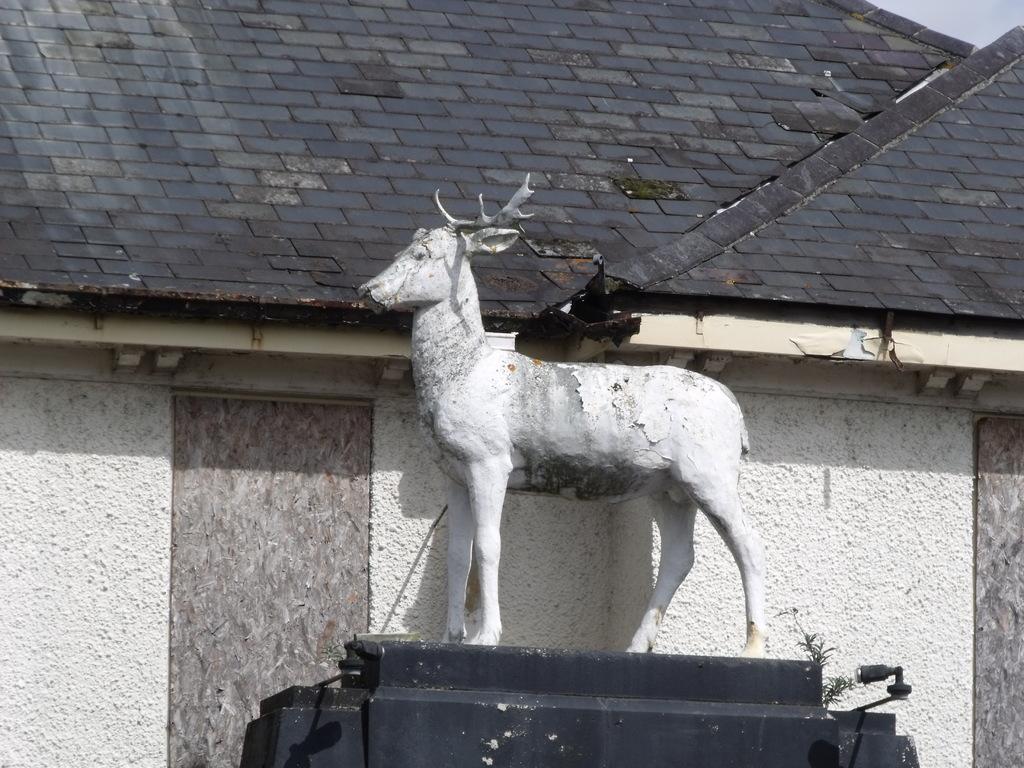How would you summarize this image in a sentence or two? In the center of the image there is a sculpture. In the background there are sheds. 